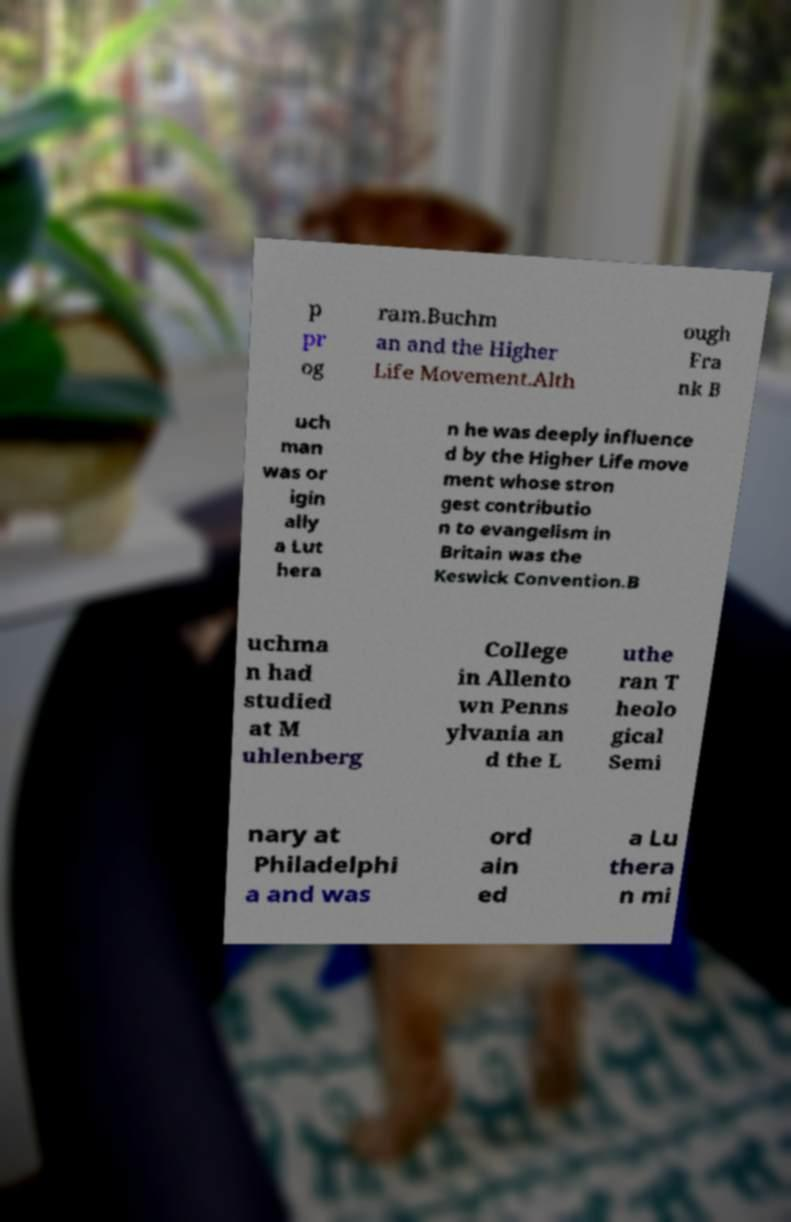Can you read and provide the text displayed in the image?This photo seems to have some interesting text. Can you extract and type it out for me? p pr og ram.Buchm an and the Higher Life Movement.Alth ough Fra nk B uch man was or igin ally a Lut hera n he was deeply influence d by the Higher Life move ment whose stron gest contributio n to evangelism in Britain was the Keswick Convention.B uchma n had studied at M uhlenberg College in Allento wn Penns ylvania an d the L uthe ran T heolo gical Semi nary at Philadelphi a and was ord ain ed a Lu thera n mi 